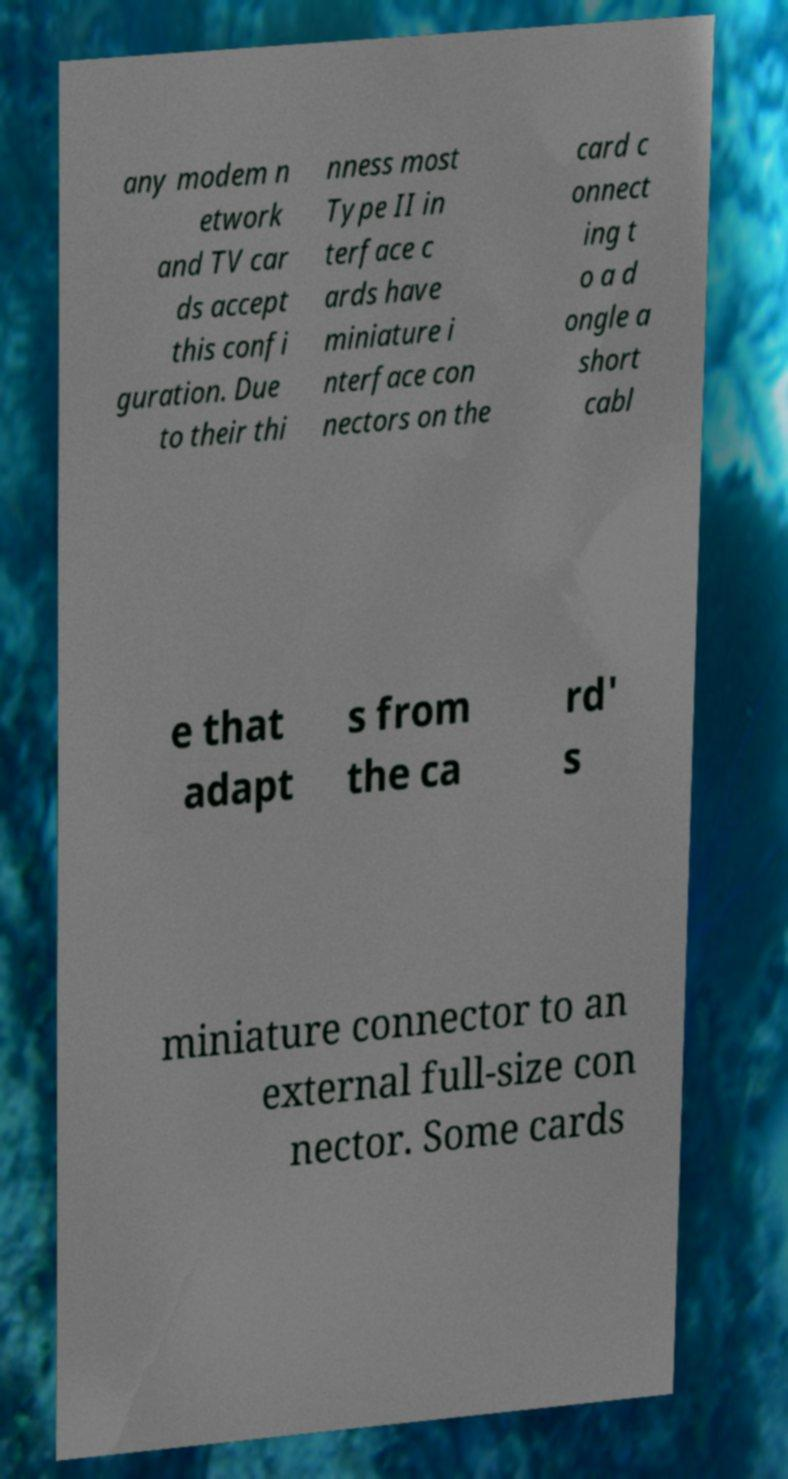There's text embedded in this image that I need extracted. Can you transcribe it verbatim? any modem n etwork and TV car ds accept this confi guration. Due to their thi nness most Type II in terface c ards have miniature i nterface con nectors on the card c onnect ing t o a d ongle a short cabl e that adapt s from the ca rd' s miniature connector to an external full-size con nector. Some cards 